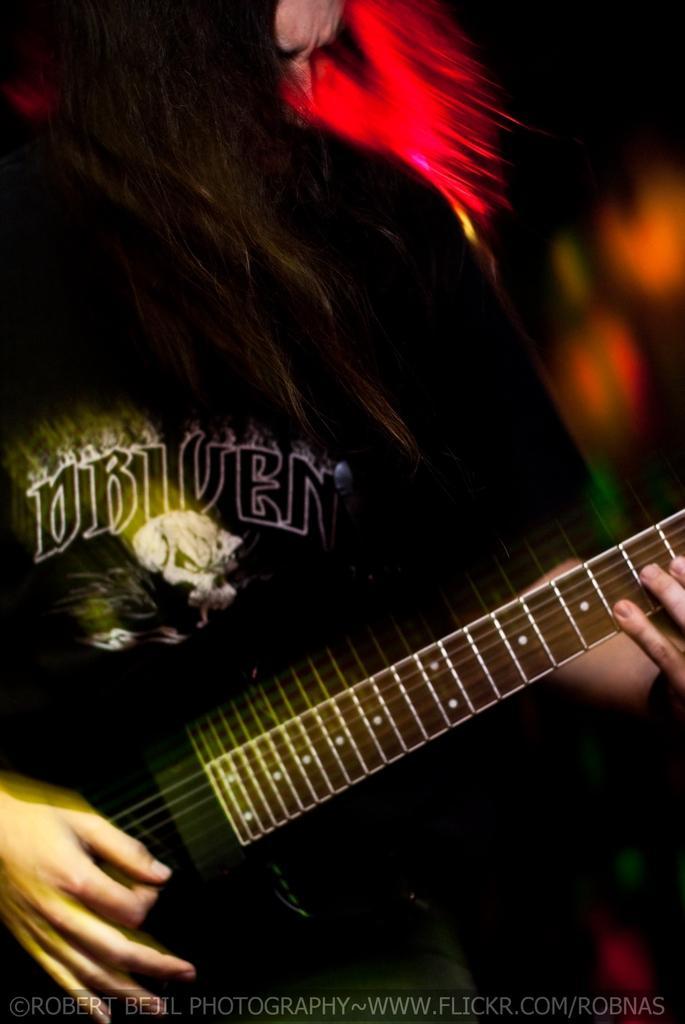In one or two sentences, can you explain what this image depicts? In front of the image there is a person holding the guitar and the background of the image is blur. There is some text at the bottom of the image. 